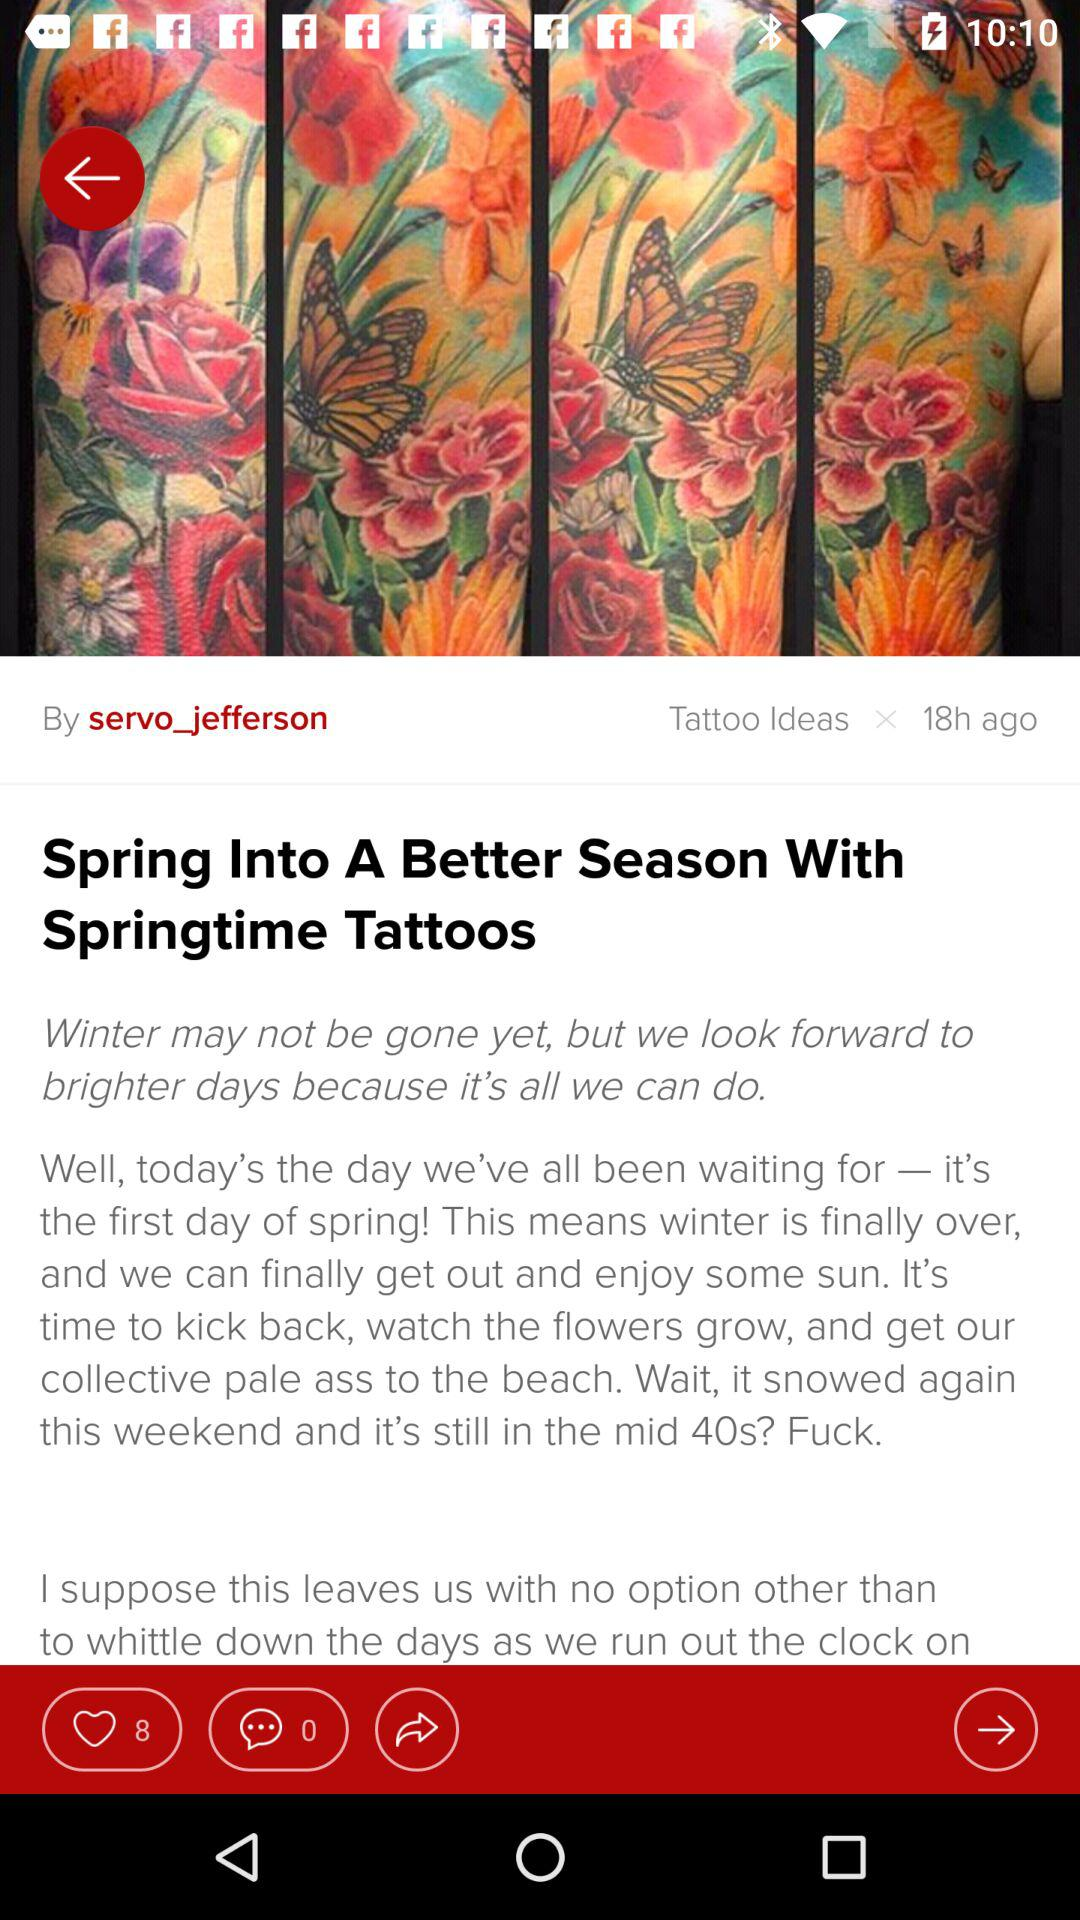How many more likes does the post have than comments?
Answer the question using a single word or phrase. 8 